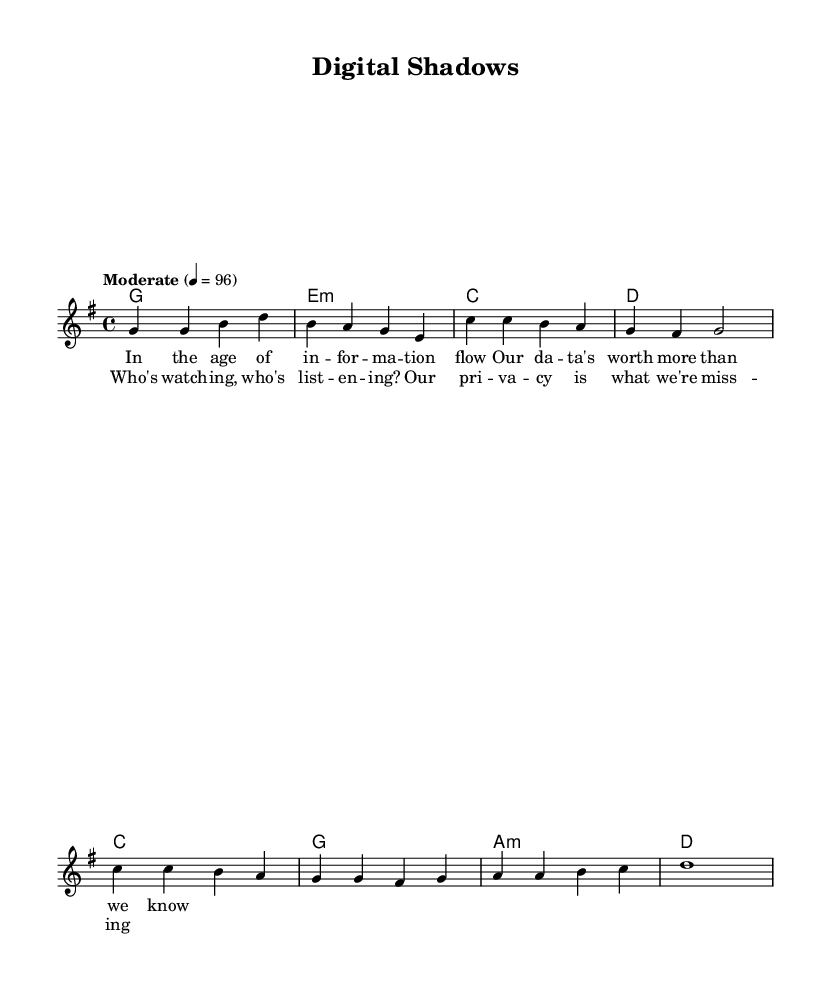What is the key signature of this music? The key signature is G major, which has one sharp (F#). This is found at the beginning of the staff where the key signature is indicated.
Answer: G major What is the time signature of this music? The time signature is 4/4, which is indicated at the beginning of the score. It tells us there are four beats in each measure and the quarter note gets one beat.
Answer: 4/4 What is the tempo marking of the piece? The tempo marking is "Moderate" with a metronome marking of 96 beats per minute, indicating a moderate pace. This is shown in the tempo indication at the beginning of the score.
Answer: Moderate 4 = 96 How many measures are there in the melody? The melody consists of eight measures as indicated by the grouping of notes and the bar lines present. Counting each group separated by the bar lines gives a total of eight.
Answer: Eight What are the first three notes of the chorus? The first three notes of the chorus are C, C, and B, which can be identified at the start of the chorus section indicated in the melody line.
Answer: C, C, B What type of song is this based on its theme? This song is a protest folk song addressing issues of data privacy and surveillance, which is evident in the lyrics presented alongside the melody.
Answer: Protest folk song What is the root chord of the first measure? The root chord of the first measure is G since the chord indicated at the beginning of the first measure is a G major chord.
Answer: G 